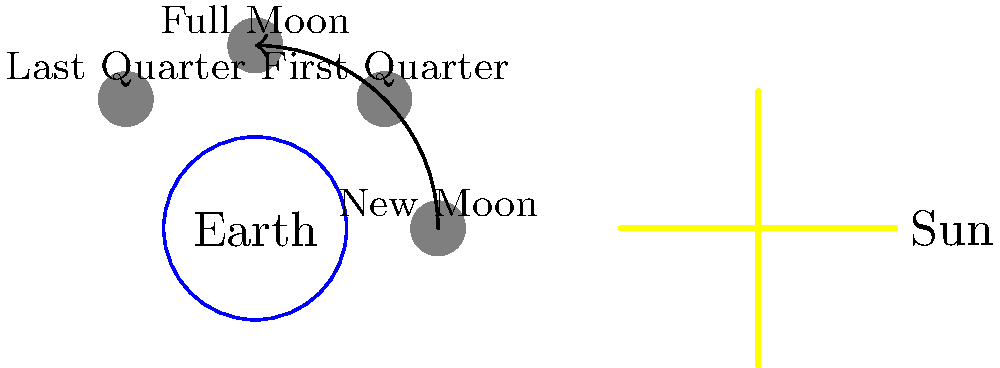Based on your experience with Raspberry Pi projects and sensor data, consider how you might use a light sensor to detect moonlight. Given the diagram showing the Earth-Moon-Sun system, in which phase would a light sensor on Earth detect the most reflected moonlight? To answer this question, let's break down the moon phases and their relationship to the Earth and Sun:

1. New Moon: The moon is between the Earth and Sun. The dark side of the moon faces Earth, so we see no reflected sunlight.

2. First Quarter: The moon is at a 90-degree angle to the Earth-Sun line. We see half of the moon's illuminated surface.

3. Full Moon: The Earth is between the moon and Sun. The fully illuminated face of the moon is visible from Earth.

4. Last Quarter: The moon is again at a 90-degree angle, but on the opposite side from the First Quarter. We see half of the moon's illuminated surface.

The amount of reflected moonlight detected by a light sensor on Earth would be directly proportional to the visible illuminated area of the moon. 

Therefore, the phase that would result in the most detected moonlight is the Full Moon. During this phase, the entire sunlit face of the moon is visible from Earth, reflecting the maximum amount of sunlight back to us.

This concept could be applied in a Raspberry Pi project by using a light-dependent resistor (LDR) or a photodiode to measure ambient light levels at night, potentially tracking moon phases over time.
Answer: Full Moon 